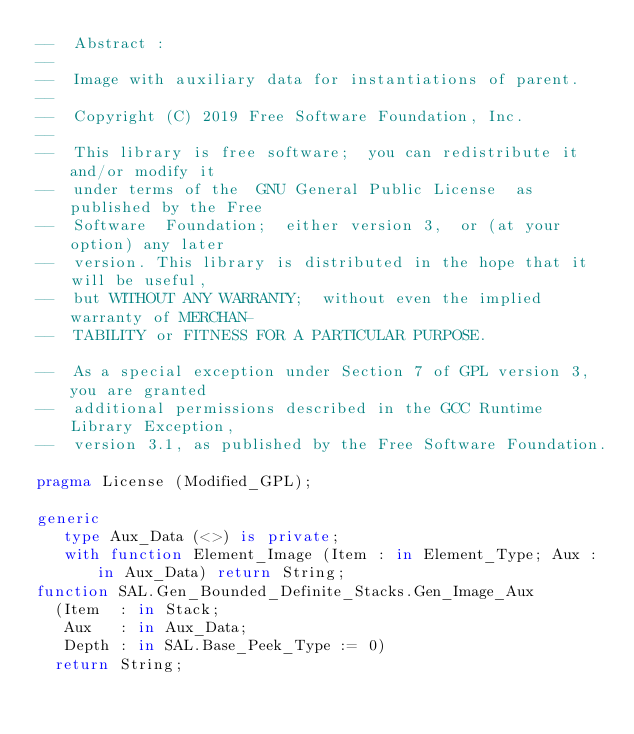Convert code to text. <code><loc_0><loc_0><loc_500><loc_500><_Ada_>--  Abstract :
--
--  Image with auxiliary data for instantiations of parent.
--
--  Copyright (C) 2019 Free Software Foundation, Inc.
--
--  This library is free software;  you can redistribute it and/or modify it
--  under terms of the  GNU General Public License  as published by the Free
--  Software  Foundation;  either version 3,  or (at your  option) any later
--  version. This library is distributed in the hope that it will be useful,
--  but WITHOUT ANY WARRANTY;  without even the implied warranty of MERCHAN-
--  TABILITY or FITNESS FOR A PARTICULAR PURPOSE.

--  As a special exception under Section 7 of GPL version 3, you are granted
--  additional permissions described in the GCC Runtime Library Exception,
--  version 3.1, as published by the Free Software Foundation.

pragma License (Modified_GPL);

generic
   type Aux_Data (<>) is private;
   with function Element_Image (Item : in Element_Type; Aux : in Aux_Data) return String;
function SAL.Gen_Bounded_Definite_Stacks.Gen_Image_Aux
  (Item  : in Stack;
   Aux   : in Aux_Data;
   Depth : in SAL.Base_Peek_Type := 0)
  return String;
</code> 